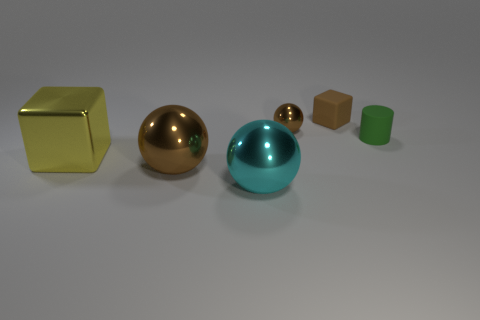Subtract all cylinders. How many objects are left? 5 Subtract all big balls. How many balls are left? 1 Subtract 1 yellow cubes. How many objects are left? 5 Subtract 3 spheres. How many spheres are left? 0 Subtract all cyan spheres. Subtract all red blocks. How many spheres are left? 2 Subtract all blue cubes. How many cyan balls are left? 1 Subtract all tiny cyan matte cylinders. Subtract all small metallic things. How many objects are left? 5 Add 4 tiny things. How many tiny things are left? 7 Add 3 balls. How many balls exist? 6 Add 2 large matte balls. How many objects exist? 8 